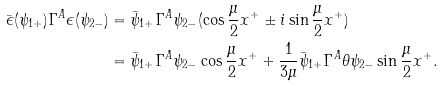Convert formula to latex. <formula><loc_0><loc_0><loc_500><loc_500>\bar { \epsilon } ( \psi _ { 1 + } ) \Gamma ^ { A } \epsilon ( \psi _ { 2 - } ) & = \bar { \psi } _ { 1 + } \Gamma ^ { A } \psi _ { 2 - } ( \cos \frac { \mu } { 2 } x ^ { + } \pm i \sin \frac { \mu } { 2 } x ^ { + } ) \\ & = \bar { \psi } _ { 1 + } \Gamma ^ { A } \psi _ { 2 - } \cos \frac { \mu } { 2 } x ^ { + } + \frac { 1 } { 3 \mu } \bar { \psi } _ { 1 + } \Gamma ^ { A } \theta \psi _ { 2 - } \sin \frac { \mu } { 2 } x ^ { + } .</formula> 